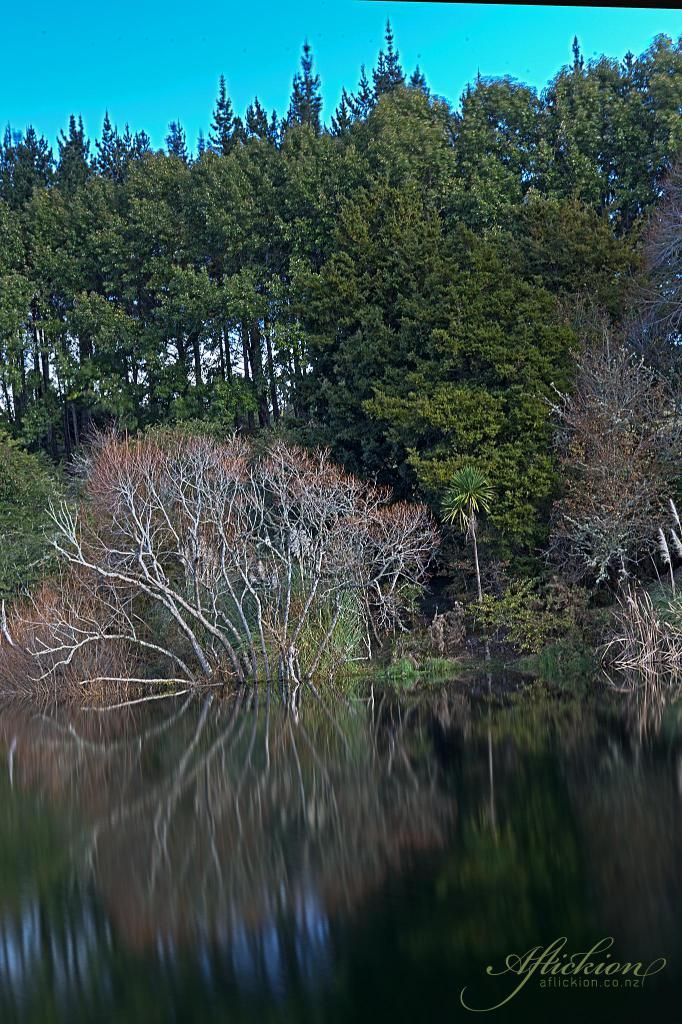What is the primary element visible in the image? There is a water surface in the image. What can be seen in the background of the image? There are trees and the sky visible in the background of the image. Where is the text located in the image? The text is in the bottom right corner of the image. What type of cover is protecting the trees from the week in the image? There is no cover or week mentioned in the image; it features a water surface, trees, and the sky in the background. 